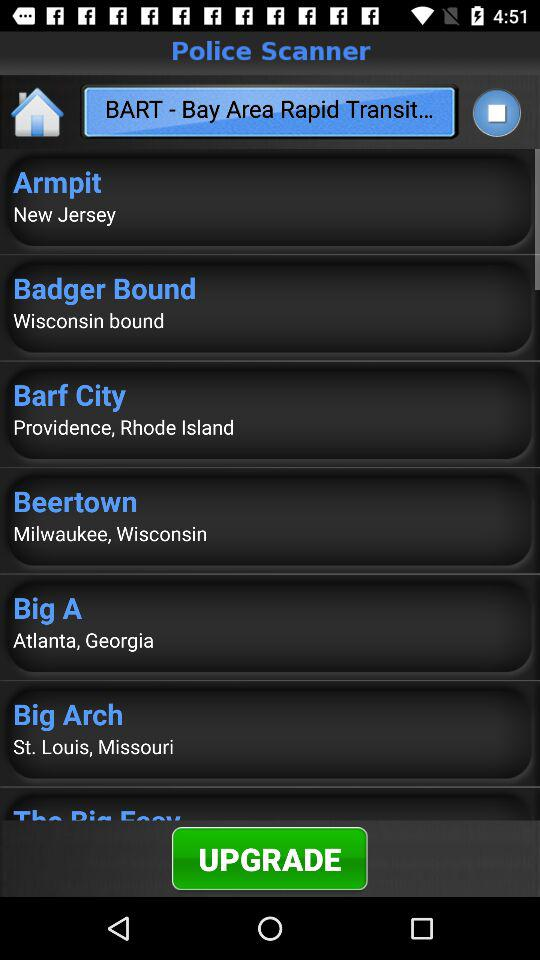What is the location of Beertown? The location of Beertown is Milwaukee, Wisconsin. 